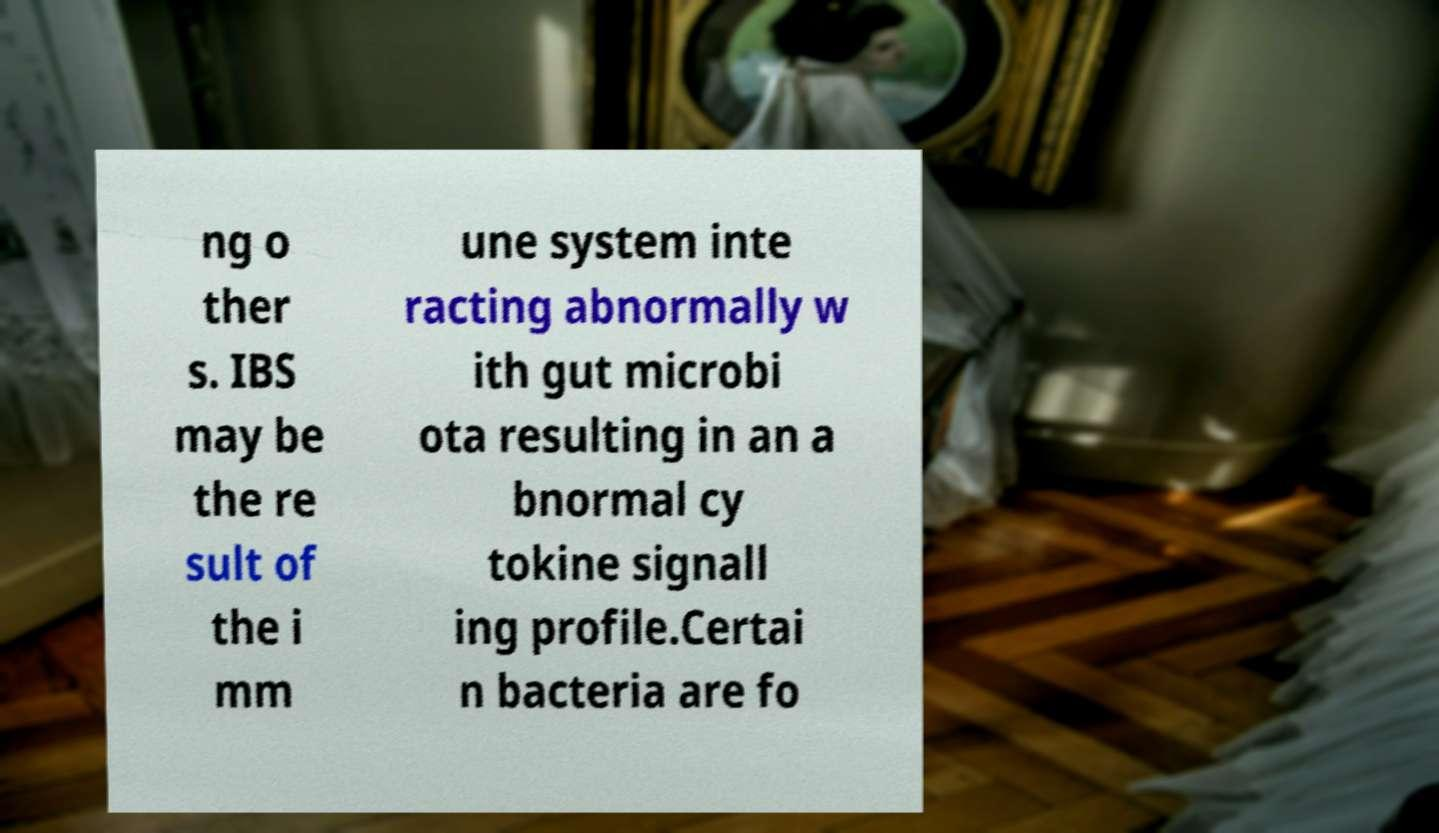What messages or text are displayed in this image? I need them in a readable, typed format. ng o ther s. IBS may be the re sult of the i mm une system inte racting abnormally w ith gut microbi ota resulting in an a bnormal cy tokine signall ing profile.Certai n bacteria are fo 